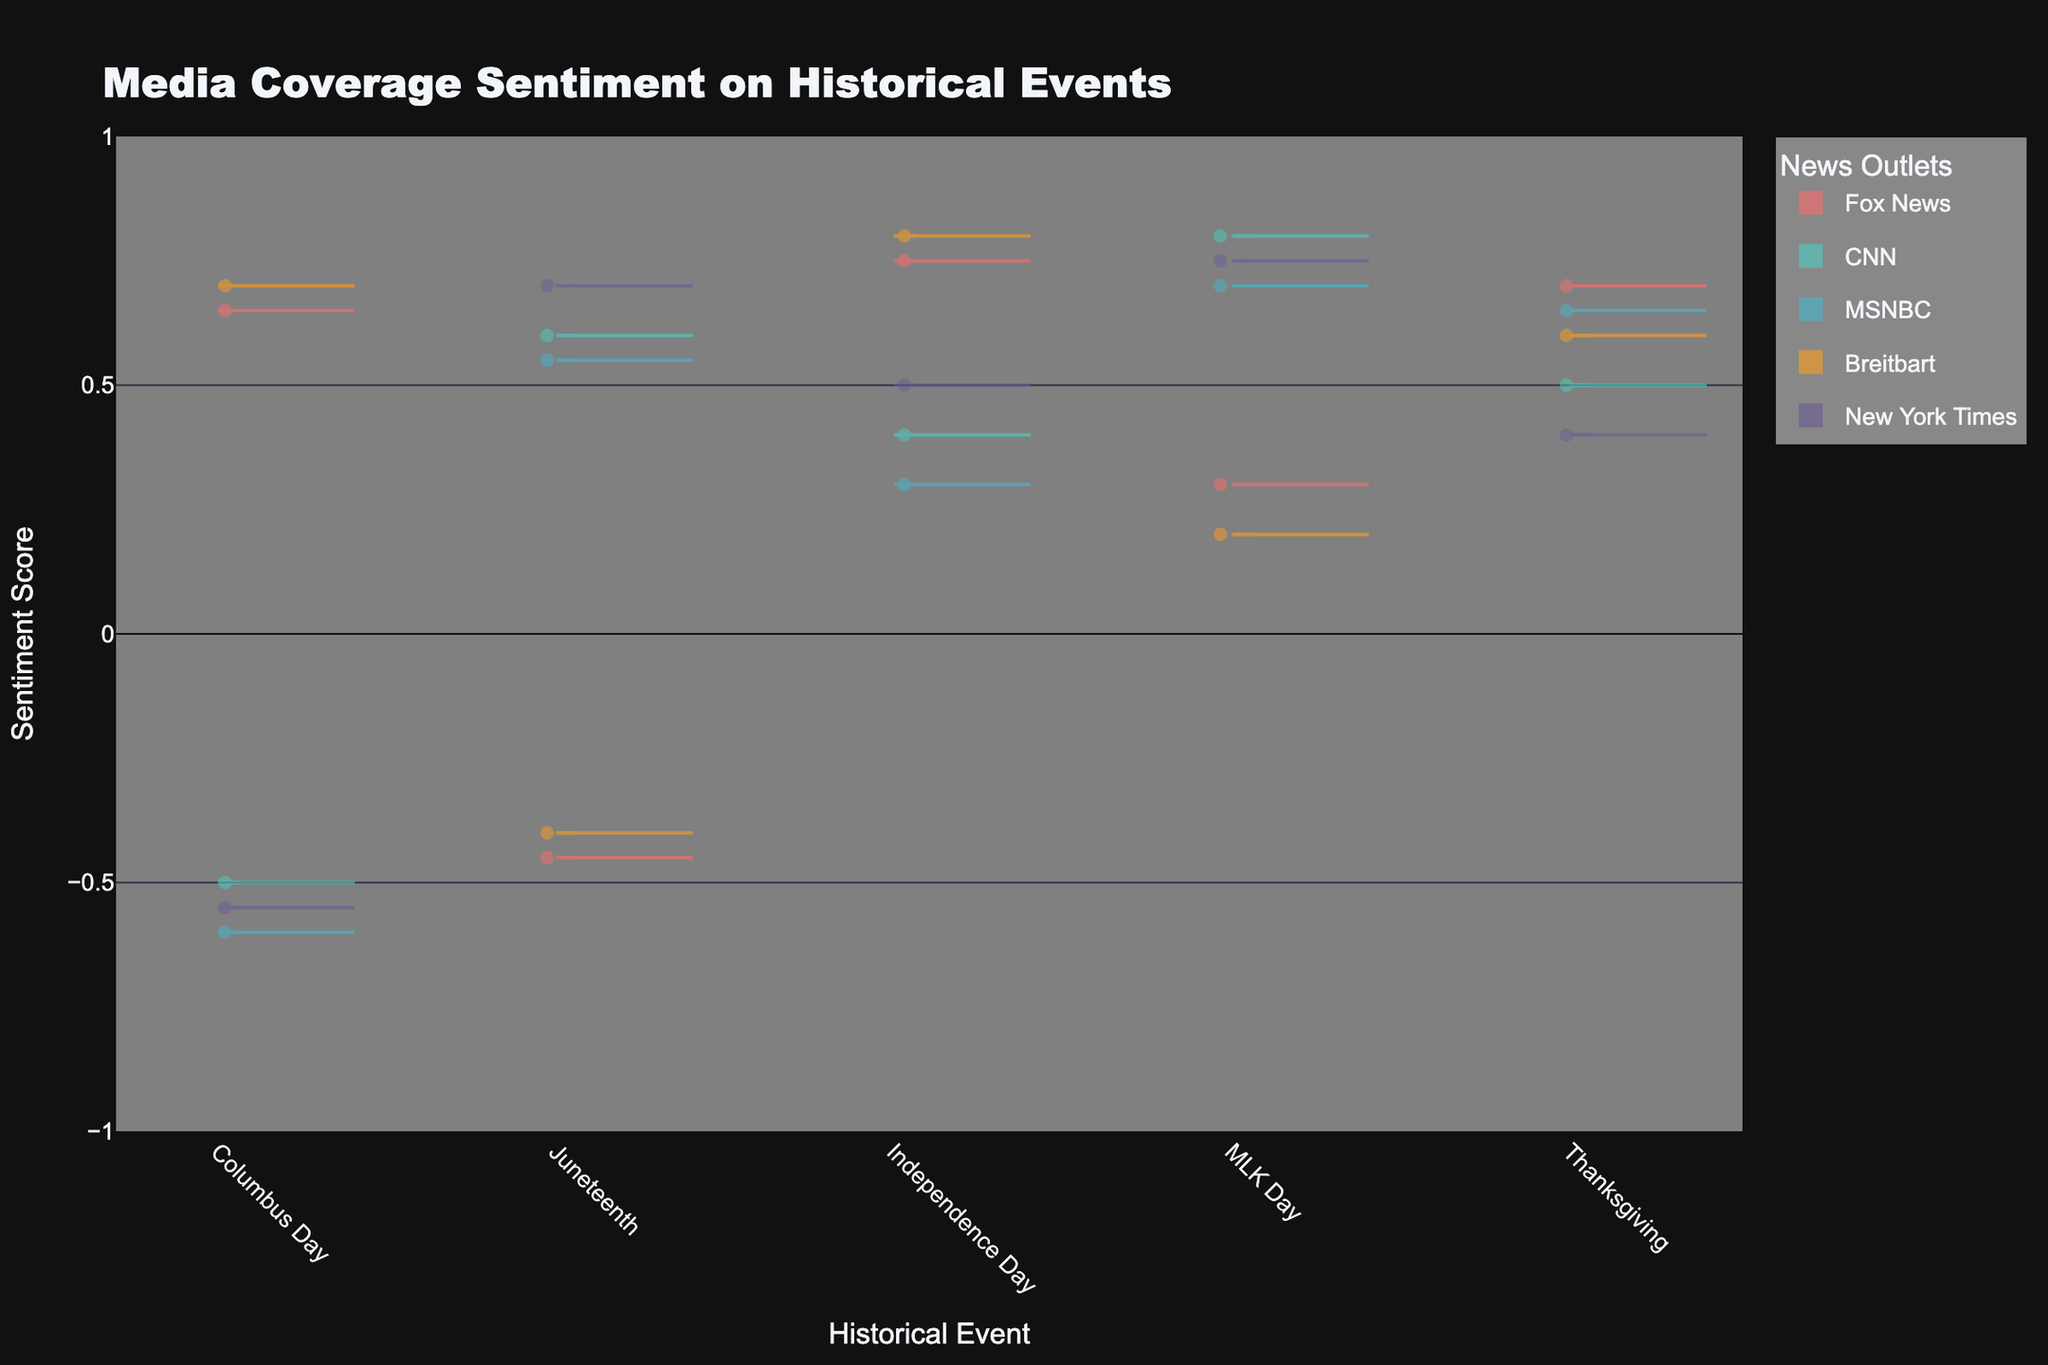What is the overall sentiment expressed by Fox News compared to CNN on Columbus Day? To determine the overall sentiment expressed by these two outlets on Columbus Day, examine their respective sentiment scores on the violin chart. Fox News has a sentiment score of 0.65 (positive), while CNN has a sentiment score of -0.5 (negative).
Answer: Fox News: Positive, CNN: Negative Which outlet has the highest sentiment score for MLK Day? Look at the sentiment scores for MLK Day across all outlets. The highest sentiment score is associated with CNN, showing a score of 0.8.
Answer: CNN What is the pattern of sentiment towards Independence Day among all outlets? Examine the sentiment scores for Independence Day across all news outlets. Fox News has 0.75, CNN has 0.4, MSNBC has 0.3, Breitbart has 0.8, and New York Times has 0.5. Most outlets have positive or mixed sentiments.
Answer: Predominantly Positive or Mixed How do the sentiments of Fox News and MSNBC compare on Juneteenth? Compare the sentiment scores for Juneteenth between Fox News and MSNBC. Fox News shows a negative sentiment (-0.45), while MSNBC shows a positive sentiment (0.55).
Answer: Fox News: Negative, MSNBC: Positive What is the average sentiment score for Thanksgiving across all outlets? Calculate the average sentiment score for Thanksgiving by summing up the individual scores (Fox News: 0.7, CNN: 0.5, MSNBC: 0.65, Breitbart: 0.6, New York Times: 0.4) and then dividing by the number of outlets (5): (0.7 + 0.5 + 0.65 + 0.6 + 0.4) / 5 = 2.85 / 5 = 0.57.
Answer: 0.57 Which historical event receives consistently negative or mixed sentiment from at least one outlet? Collect the sentiment scores for each event and identify those with at least one negative or mixed sentiment. Columbus Day (negative from CNN: -0.5, MSNBC: -0.6, and New York Times: -0.55) and Juneteenth (negative from Fox News: -0.45) have consistent negative or mixed sentiments from multiple outlets.
Answer: Columbus Day, Juneteenth What is the range of sentiments expressed by the New York Times across the different events? Identify the minimum and maximum sentiment scores for New York Times. They have -0.55 for Columbus Day (minimum) and 0.75 for MLK Day (maximum), giving a range from -0.55 to 0.75.
Answer: -0.55 to 0.75 Which outlet shows the lowest sentiment for Columbus Day? Review the sentiment scores for Columbus Day. The lowest sentiment score is found for MSNBC with a score of -0.6.
Answer: MSNBC Compare the median sentiment scores for all outlets on Juneteenth. Arrange the sentiment scores for Juneteenth for all outlets: Fox News (-0.45), CNN (0.6), MSNBC (0.55), Breitbart (-0.4), New York Times (0.7). The median value is the middle score when these are ordered: -0.45, -0.4, 0.55, 0.6, 0.7. The median is 0.55.
Answer: 0.55 